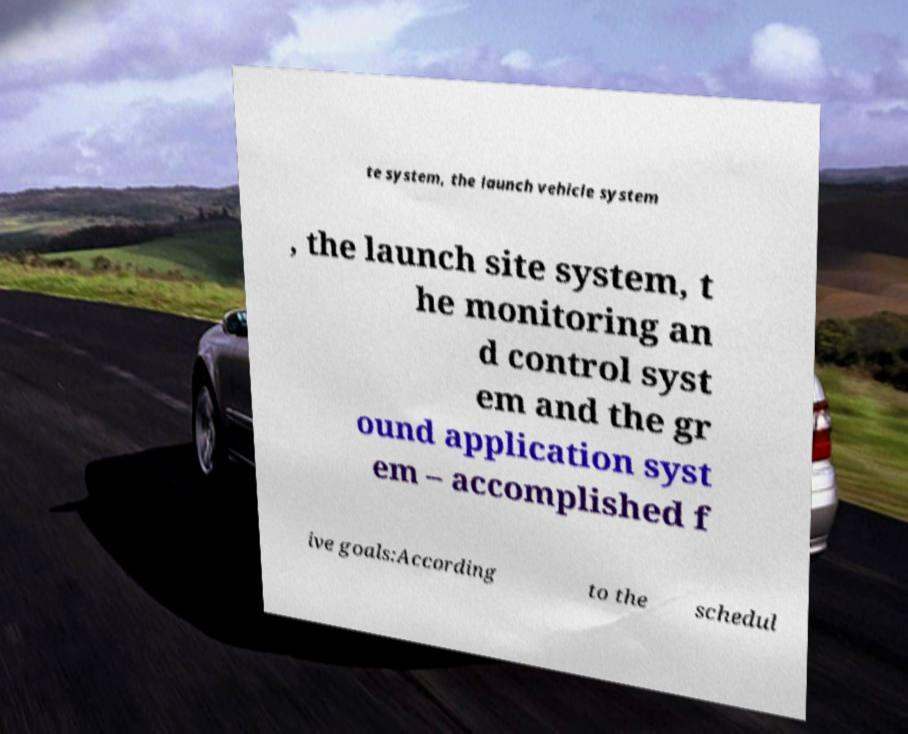For documentation purposes, I need the text within this image transcribed. Could you provide that? te system, the launch vehicle system , the launch site system, t he monitoring an d control syst em and the gr ound application syst em – accomplished f ive goals:According to the schedul 